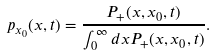Convert formula to latex. <formula><loc_0><loc_0><loc_500><loc_500>p _ { x _ { 0 } } ( x , t ) = \frac { P _ { + } ( x , x _ { 0 } , t ) } { \int _ { 0 } ^ { \infty } d x P _ { + } ( x , x _ { 0 } , t ) } .</formula> 